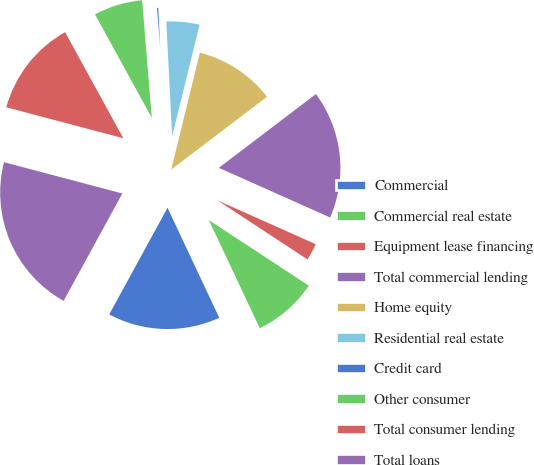<chart> <loc_0><loc_0><loc_500><loc_500><pie_chart><fcel>Commercial<fcel>Commercial real estate<fcel>Equipment lease financing<fcel>Total commercial lending<fcel>Home equity<fcel>Residential real estate<fcel>Credit card<fcel>Other consumer<fcel>Total consumer lending<fcel>Total loans<nl><fcel>14.96%<fcel>8.76%<fcel>2.56%<fcel>17.02%<fcel>10.83%<fcel>4.63%<fcel>0.5%<fcel>6.69%<fcel>12.89%<fcel>21.15%<nl></chart> 